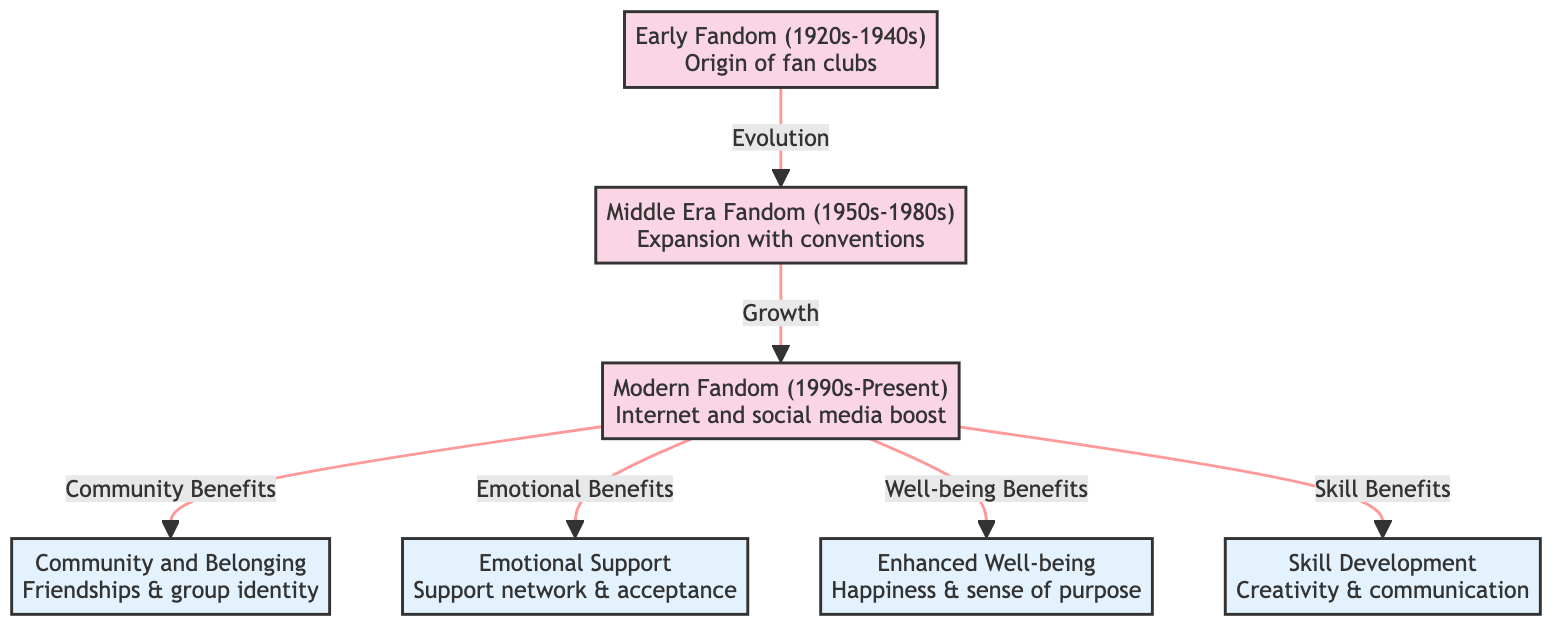What era marked the beginning of fan clubs? The diagram shows that the "Early Fandom" from the 1920s to the 1940s is where fan clubs originated. Therefore, the answer is based on the information in the first node.
Answer: Early Fandom (1920s-1940s) How many psychological benefits are listed in the diagram? Counting the benefits listed, there are four distinct benefits: Community and Belonging, Emotional Support, Enhanced Well-being, and Skill Development. Therefore, the answer is based on the number of benefits nodes in the diagram.
Answer: 4 What evolution led to the Middle Era Fandom? The connecting arrow indicates that "Evolution" is the relationship between the "Early Fandom" and "Middle Era Fandom," signifying progress from one to the other. Hence, the answer is derived from the relationship noted beside the nodes.
Answer: Evolution Which era is associated with the boost from the Internet and social media? The diagram states that "Modern Fandom (1990s-Present)" is the era characterized by the boost from the Internet and social media. This is found in the description of the node for the Modern Fandom era.
Answer: Modern Fandom (1990s-Present) What is the main focus of the "Community Benefits"? The diagram links "Community and Belonging" with "Modern Fandom," indicating a key aspect of the community's psychological benefits. Therefore, the focus can be found by following the flow from Modern Fandom to its benefits.
Answer: Friendships & group identity What connections are represented by the shaded edges in the diagram? The shaded edges connect the era nodes to the benefits nodes. The different link styles highlight the flow of evolution, growth, and community benefits, hence indicating their relationships within the graphic.
Answer: Evolution, Growth, Community Benefits Which benefit relates to feelings of happiness and sense of purpose? The "Enhanced Well-being" node clearly points to happiness and a sense of purpose as its associated aspects, based on the information provided in that node.
Answer: Enhanced Well-being Which psychological benefit emphasizes creativity and communication? The node labeled "Skill Development" specifically mentions that it encompasses creativity and communication; therefore, this benefit is what the question seeks.
Answer: Skill Development 